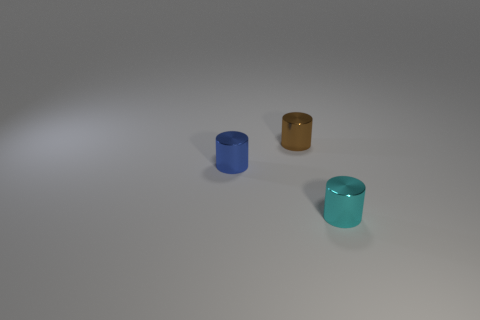Do the small blue thing and the cyan object have the same shape?
Your answer should be compact. Yes. There is a blue cylinder to the left of the brown metallic cylinder; how big is it?
Provide a succinct answer. Small. There is a blue cylinder; is it the same size as the metal cylinder right of the small brown metallic cylinder?
Give a very brief answer. Yes. Is the number of small cyan objects right of the cyan object less than the number of blue cylinders?
Provide a succinct answer. Yes. What is the material of the blue object that is the same shape as the small brown shiny thing?
Provide a short and direct response. Metal. What is the shape of the metal object that is in front of the brown thing and on the right side of the small blue shiny cylinder?
Provide a succinct answer. Cylinder. The cyan thing that is the same material as the tiny blue object is what shape?
Offer a terse response. Cylinder. There is a object behind the tiny blue metallic thing; what is its material?
Your answer should be very brief. Metal. Does the shiny cylinder in front of the blue thing have the same size as the metal cylinder behind the small blue metal object?
Make the answer very short. Yes. Does the tiny thing that is to the right of the brown metallic cylinder have the same shape as the brown shiny object?
Provide a succinct answer. Yes. 